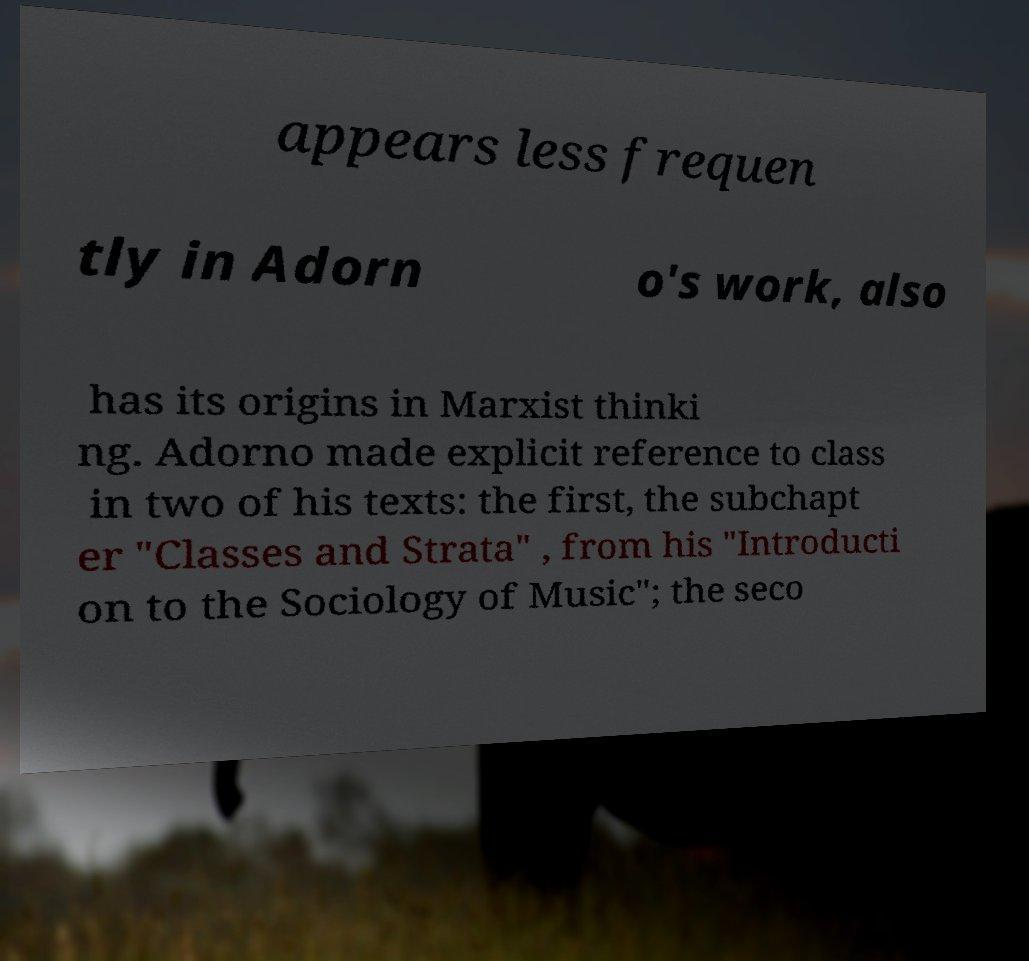Can you read and provide the text displayed in the image?This photo seems to have some interesting text. Can you extract and type it out for me? appears less frequen tly in Adorn o's work, also has its origins in Marxist thinki ng. Adorno made explicit reference to class in two of his texts: the first, the subchapt er "Classes and Strata" , from his "Introducti on to the Sociology of Music"; the seco 